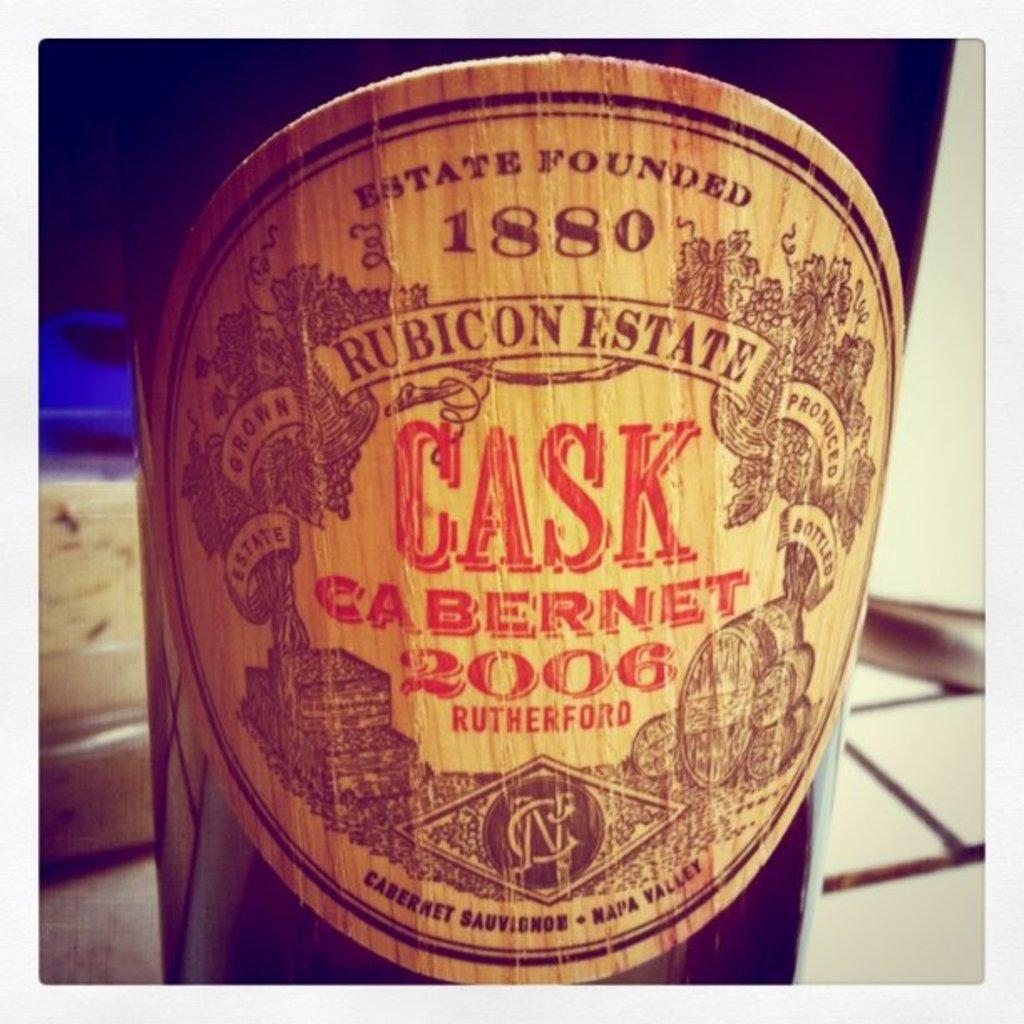<image>
Give a short and clear explanation of the subsequent image. Cask Cabernet 2006 is printed on the label for this wine bottle. 